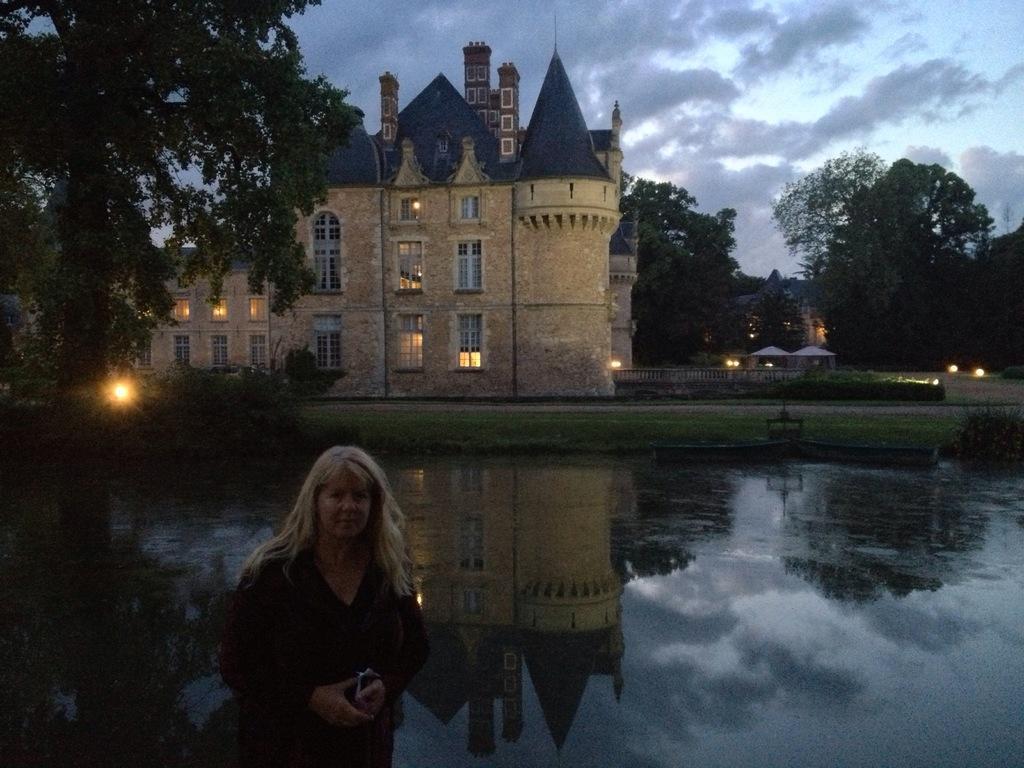Please provide a concise description of this image. In this image I can see a person standing and can see there is a building, and to the right side of the image there are two gazebos. There is a building reflection in the water ,there are trees, and in the background there is sky with clouds. 